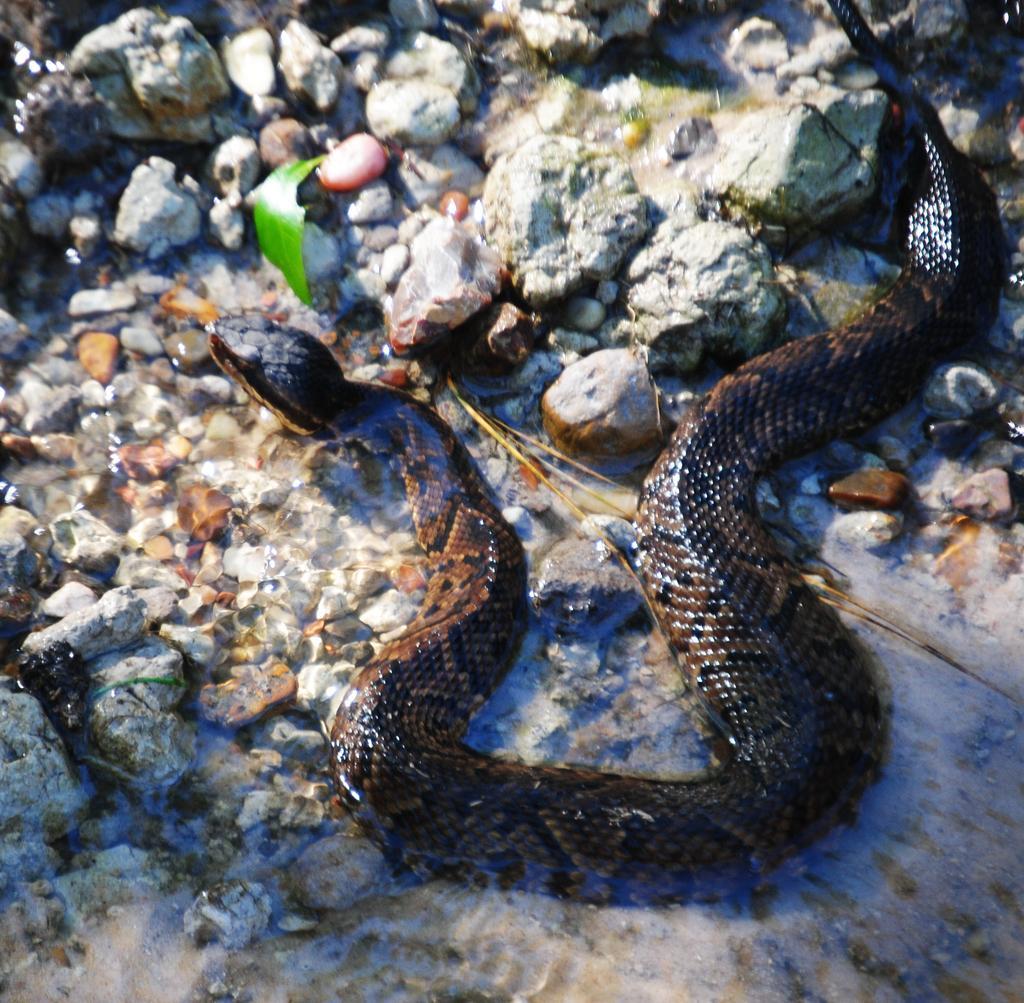In one or two sentences, can you explain what this image depicts? In this picture we can see a snake and there are stones. 